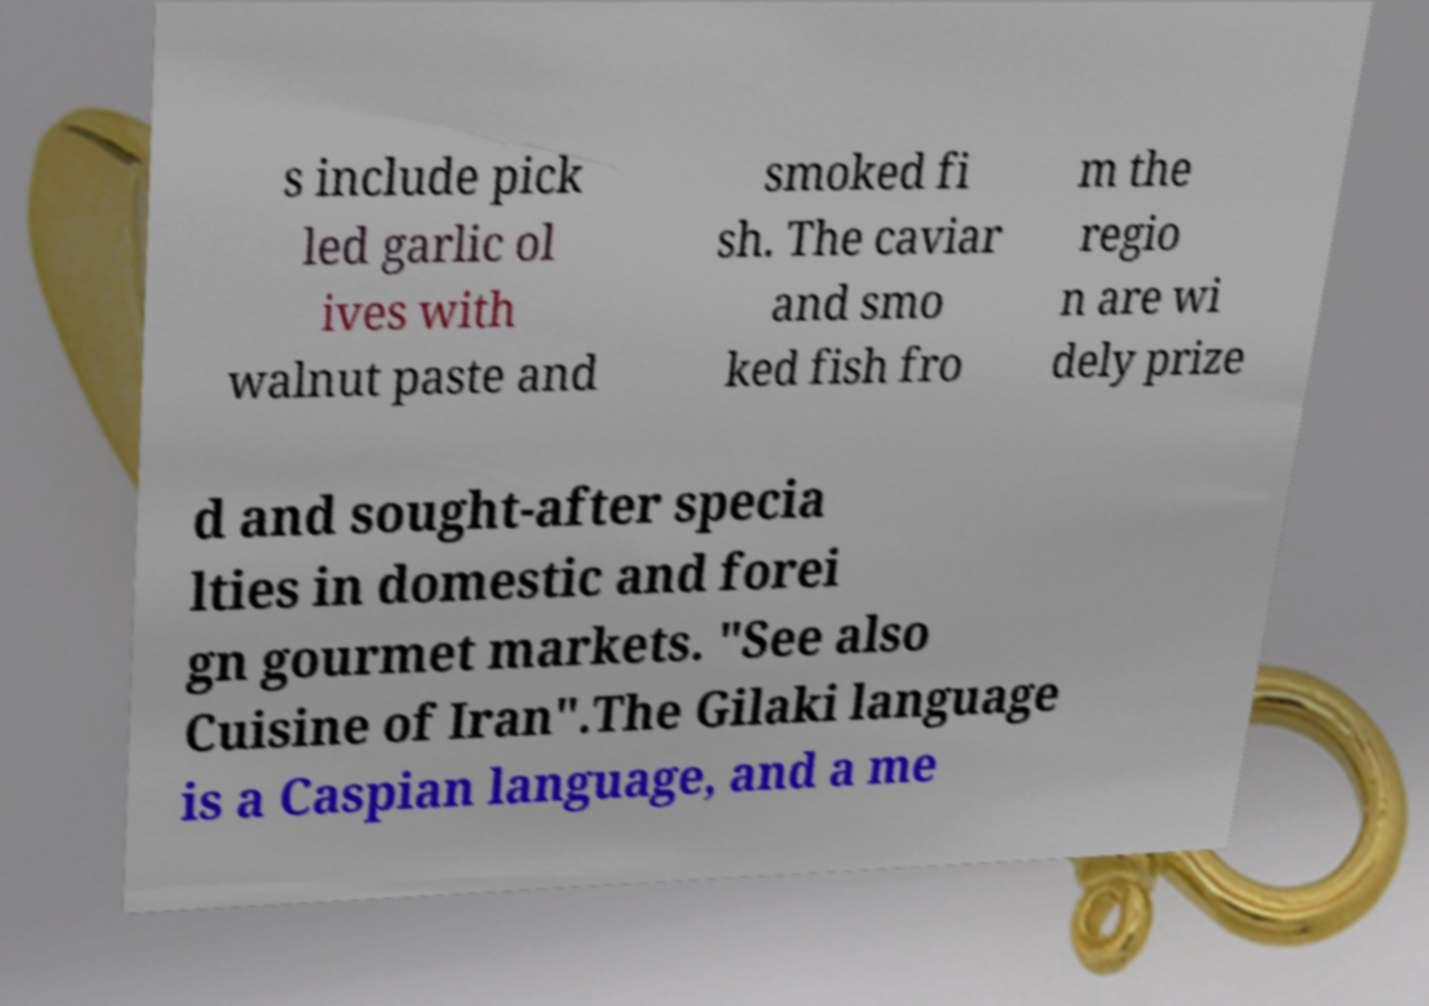Could you assist in decoding the text presented in this image and type it out clearly? s include pick led garlic ol ives with walnut paste and smoked fi sh. The caviar and smo ked fish fro m the regio n are wi dely prize d and sought-after specia lties in domestic and forei gn gourmet markets. "See also Cuisine of Iran".The Gilaki language is a Caspian language, and a me 